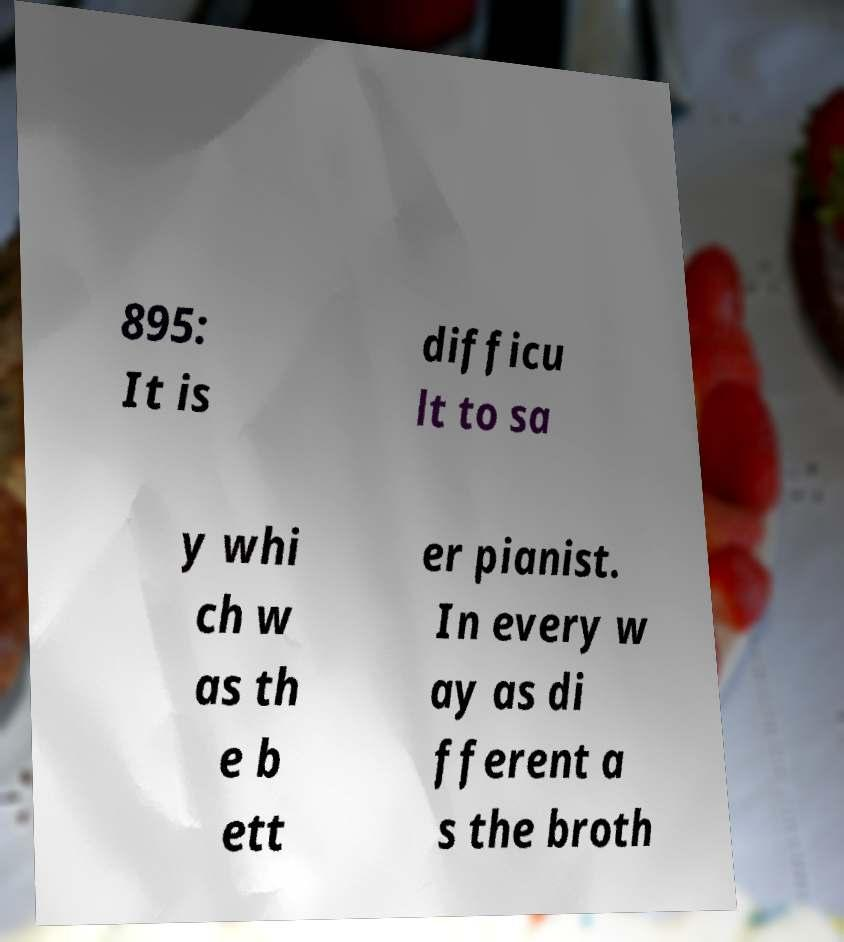What messages or text are displayed in this image? I need them in a readable, typed format. 895: It is difficu lt to sa y whi ch w as th e b ett er pianist. In every w ay as di fferent a s the broth 